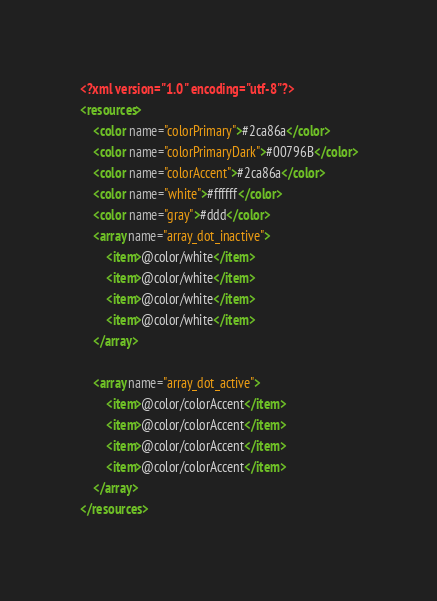<code> <loc_0><loc_0><loc_500><loc_500><_XML_><?xml version="1.0" encoding="utf-8"?>
<resources>
    <color name="colorPrimary">#2ca86a</color>
    <color name="colorPrimaryDark">#00796B</color>
    <color name="colorAccent">#2ca86a</color>
    <color name="white">#ffffff</color>
    <color name="gray">#ddd</color>
    <array name="array_dot_inactive">
        <item>@color/white</item>
        <item>@color/white</item>
        <item>@color/white</item>
        <item>@color/white</item>
    </array>

    <array name="array_dot_active">
        <item>@color/colorAccent</item>
        <item>@color/colorAccent</item>
        <item>@color/colorAccent</item>
        <item>@color/colorAccent</item>
    </array>
</resources>
</code> 